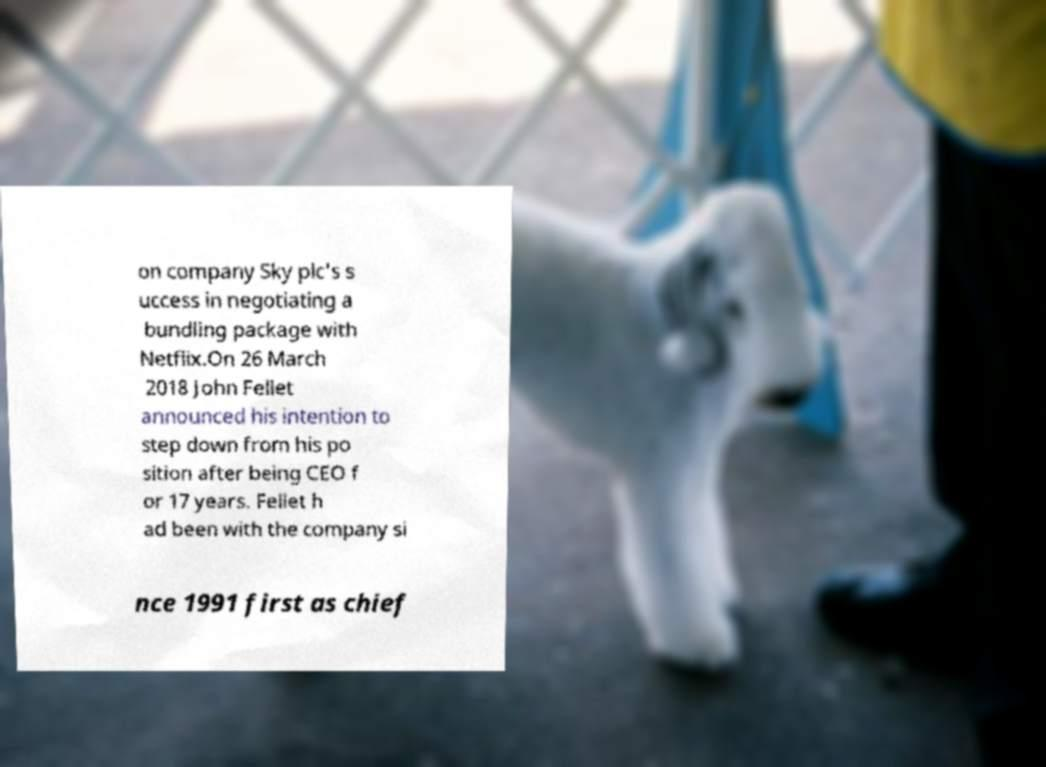Could you extract and type out the text from this image? on company Sky plc's s uccess in negotiating a bundling package with Netflix.On 26 March 2018 John Fellet announced his intention to step down from his po sition after being CEO f or 17 years. Fellet h ad been with the company si nce 1991 first as chief 